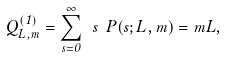Convert formula to latex. <formula><loc_0><loc_0><loc_500><loc_500>Q ^ { ( 1 ) } _ { L , m } = \sum ^ { \infty } _ { s = 0 } \ s \ P ( s ; L , m ) = m L ,</formula> 